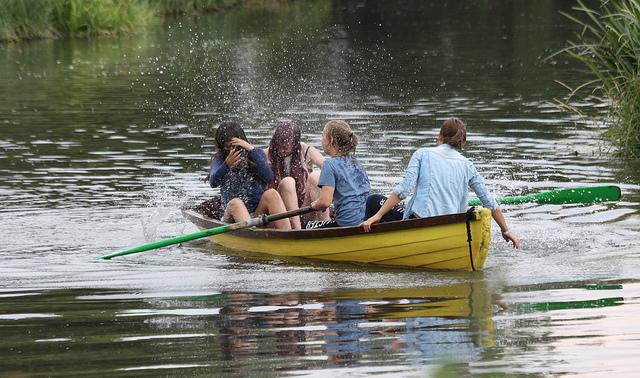What is the green item? Please explain your reasoning. oar. The green device with black handle sticking out either side of this boat is for rowing and maneuvering the boat through water. 